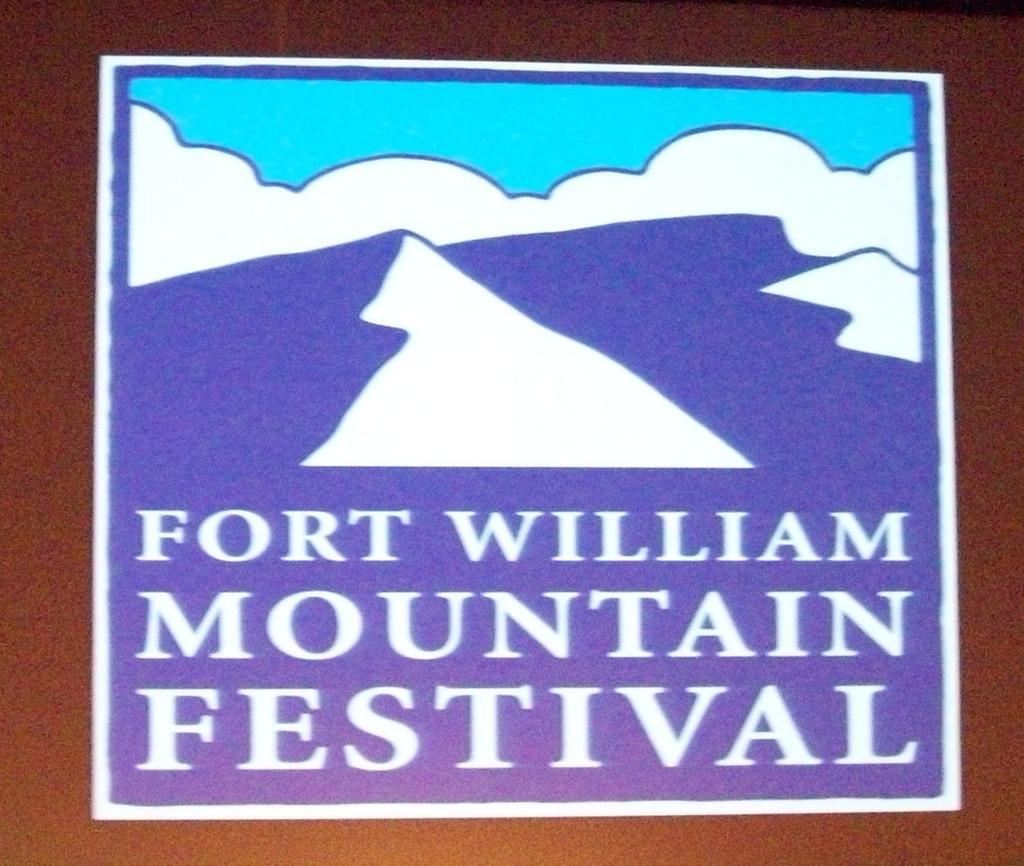<image>
Summarize the visual content of the image. A sign for the Fort William Mountain Festival features mountains. 